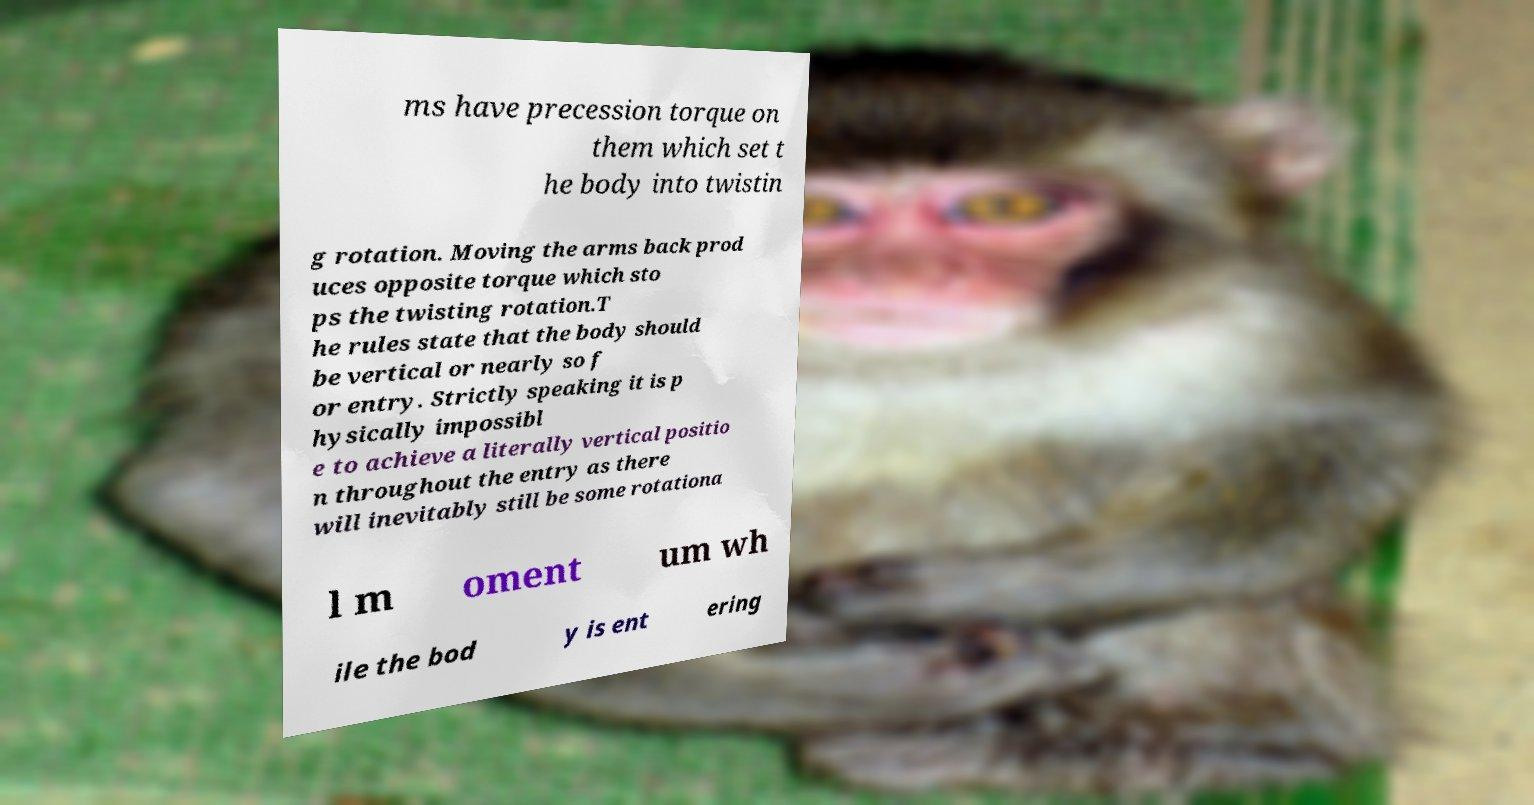Could you assist in decoding the text presented in this image and type it out clearly? ms have precession torque on them which set t he body into twistin g rotation. Moving the arms back prod uces opposite torque which sto ps the twisting rotation.T he rules state that the body should be vertical or nearly so f or entry. Strictly speaking it is p hysically impossibl e to achieve a literally vertical positio n throughout the entry as there will inevitably still be some rotationa l m oment um wh ile the bod y is ent ering 